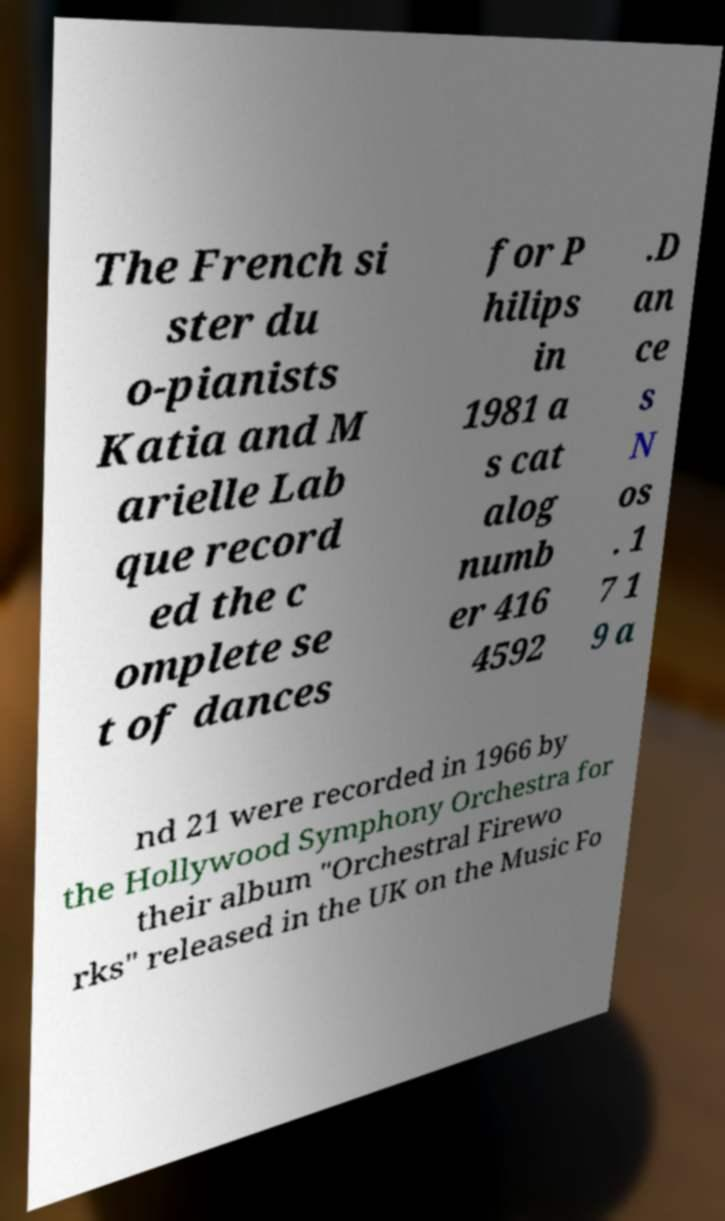There's text embedded in this image that I need extracted. Can you transcribe it verbatim? The French si ster du o-pianists Katia and M arielle Lab que record ed the c omplete se t of dances for P hilips in 1981 a s cat alog numb er 416 4592 .D an ce s N os . 1 7 1 9 a nd 21 were recorded in 1966 by the Hollywood Symphony Orchestra for their album "Orchestral Firewo rks" released in the UK on the Music Fo 